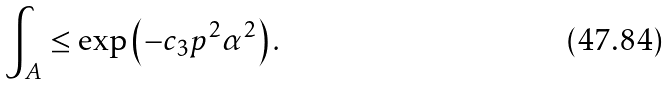<formula> <loc_0><loc_0><loc_500><loc_500>\int _ { A } \leq \exp \left ( - c _ { 3 } p ^ { 2 } \alpha ^ { 2 } \right ) .</formula> 